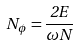Convert formula to latex. <formula><loc_0><loc_0><loc_500><loc_500>N _ { \phi } = \frac { 2 E } { \omega N }</formula> 